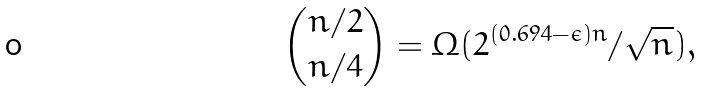Convert formula to latex. <formula><loc_0><loc_0><loc_500><loc_500>\binom { n / 2 } { n / 4 } = \Omega ( 2 ^ { ( 0 . 6 9 4 - \epsilon ) n } / \sqrt { n } ) ,</formula> 